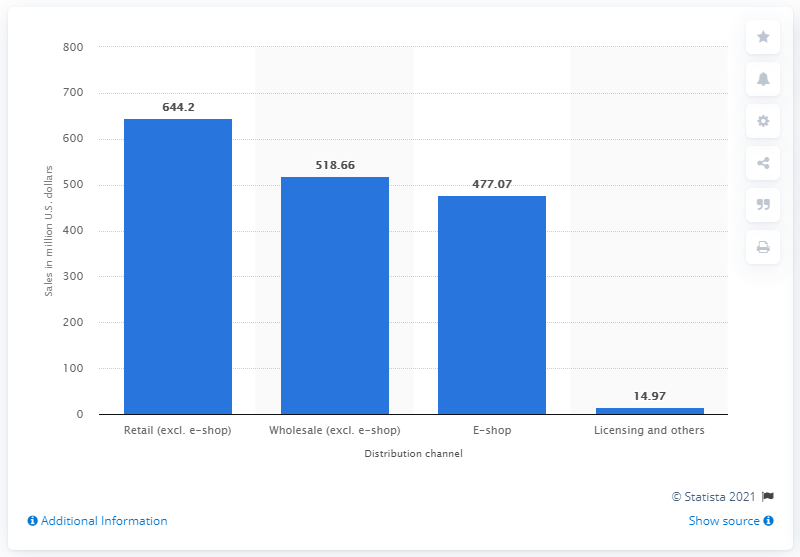Mention a couple of crucial points in this snapshot. In the year 2018/2019, ESPRIT's retail sales generated a total of 644.2 dollars. 